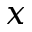<formula> <loc_0><loc_0><loc_500><loc_500>x</formula> 